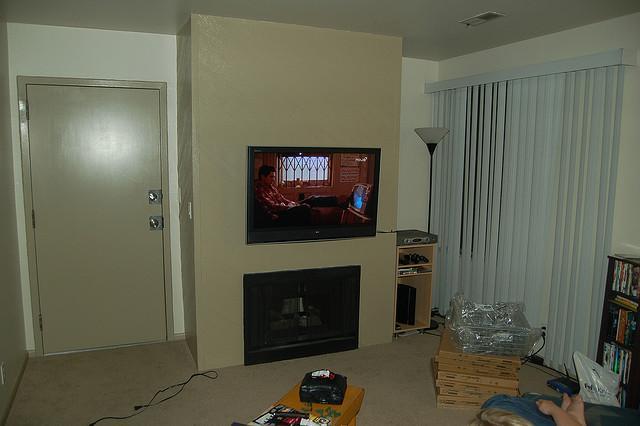How many people can you see?
Give a very brief answer. 2. How many tvs can be seen?
Give a very brief answer. 2. 